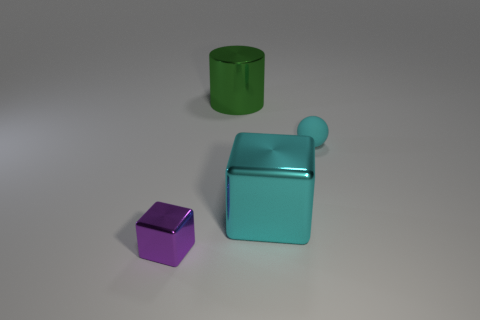Add 2 large blue things. How many objects exist? 6 Subtract all cylinders. How many objects are left? 3 Subtract 1 cylinders. How many cylinders are left? 0 Subtract all green blocks. How many purple spheres are left? 0 Subtract all large gray metallic objects. Subtract all cyan matte balls. How many objects are left? 3 Add 4 tiny cyan rubber things. How many tiny cyan rubber things are left? 5 Add 3 purple objects. How many purple objects exist? 4 Subtract 0 cyan cylinders. How many objects are left? 4 Subtract all green blocks. Subtract all green cylinders. How many blocks are left? 2 